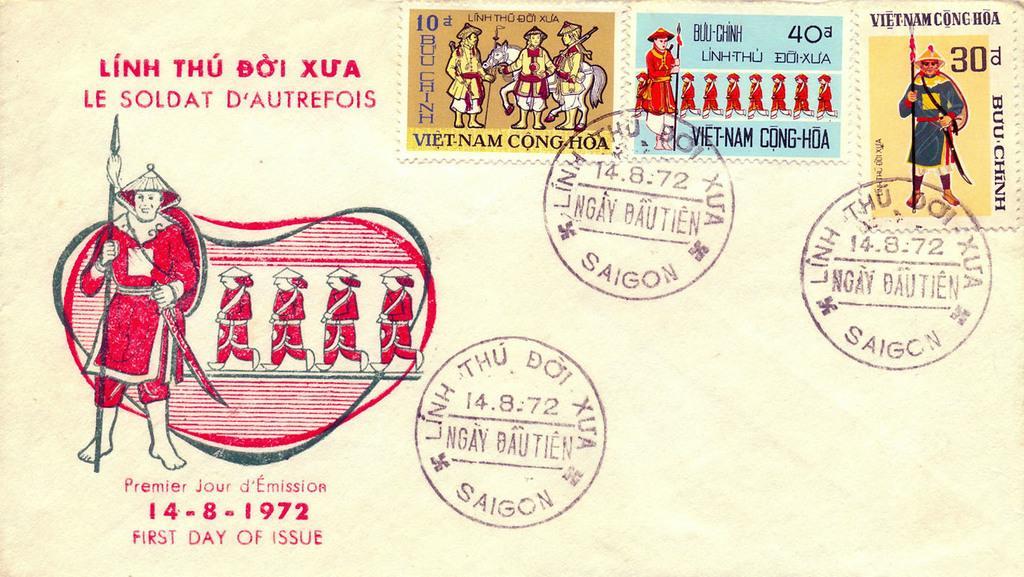Describe this image in one or two sentences. In this image there is a card. There are stamps, depictions of persons, stamps on it. 